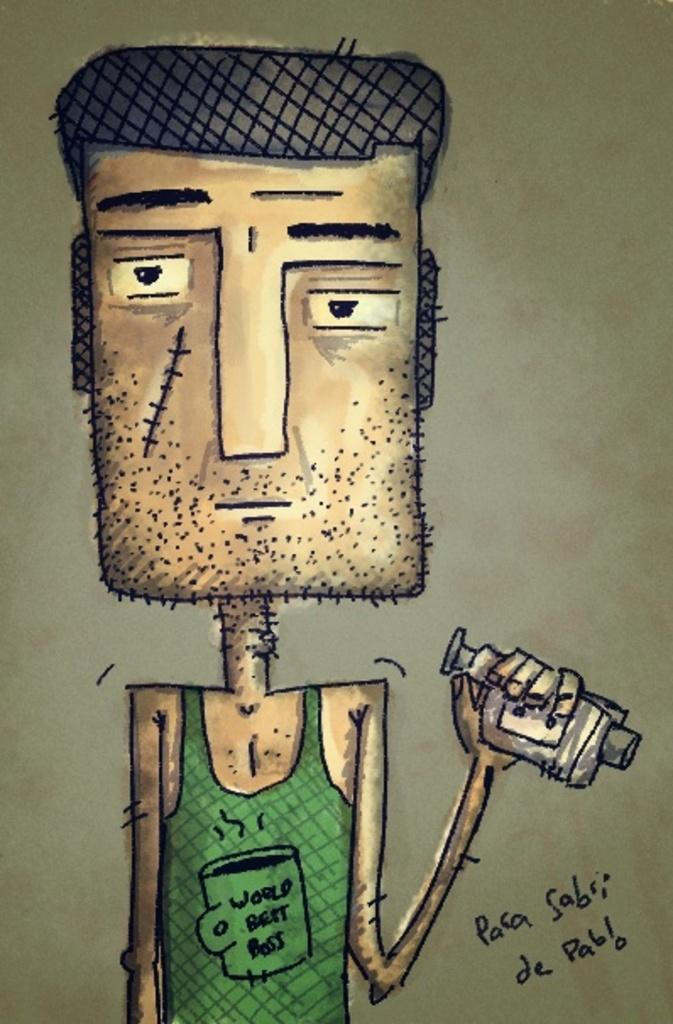What is the main subject of the image? The main subject of the image is an animated picture of a man. What is the man wearing in the image? The man is wearing a green dress in the image. What is the man holding in his hand? The man is holding items in his hand in the image. What color is the background of the image? The background of the image is brown. What type of company does the man's father work for in the image? There is no information about the man's father or any company in the image. What is the man using to iron his clothes in the image? There is no iron or any indication of clothes-ironing activity in the image. 